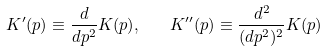Convert formula to latex. <formula><loc_0><loc_0><loc_500><loc_500>K ^ { \prime } ( p ) \equiv \frac { d } { d p ^ { 2 } } K ( p ) , \quad K ^ { \prime \prime } ( p ) \equiv \frac { d ^ { 2 } } { ( d p ^ { 2 } ) ^ { 2 } } K ( p )</formula> 